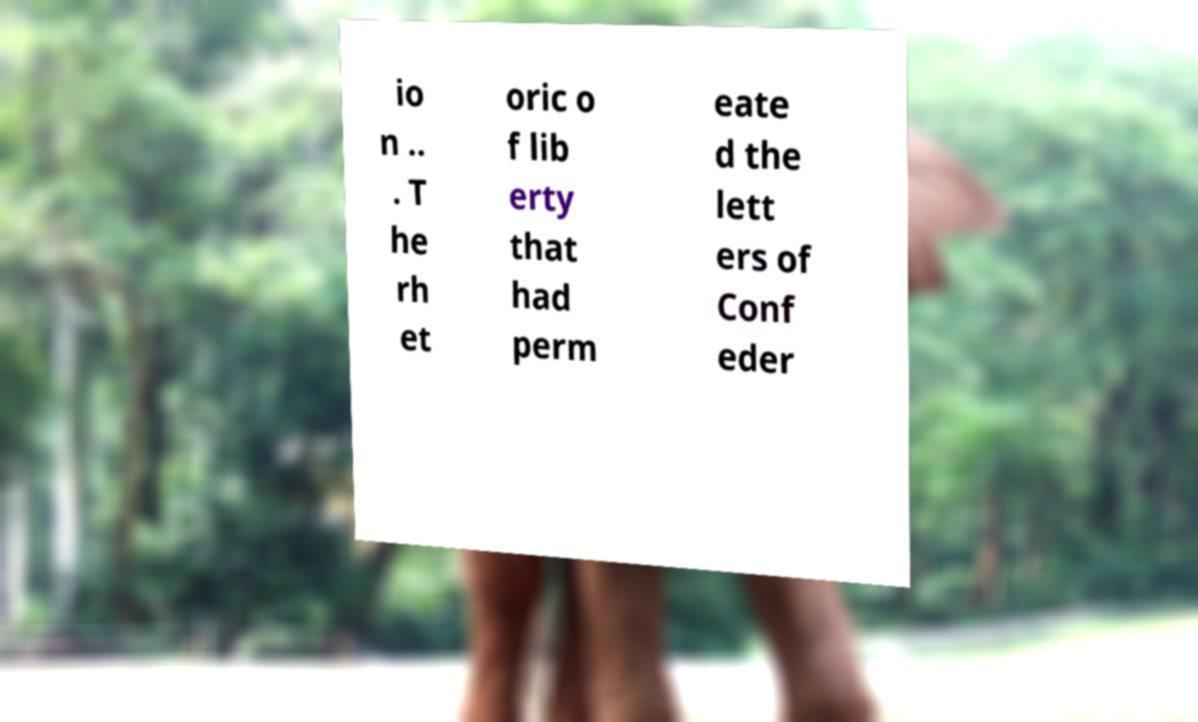I need the written content from this picture converted into text. Can you do that? io n .. . T he rh et oric o f lib erty that had perm eate d the lett ers of Conf eder 